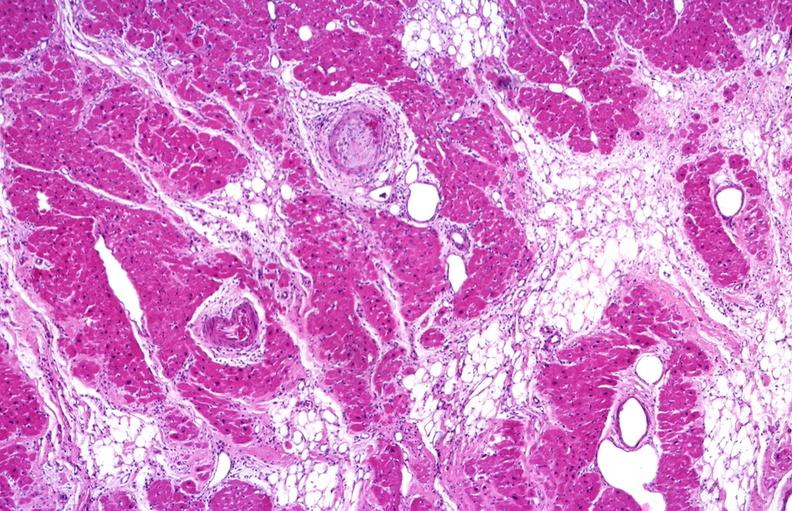s marked present?
Answer the question using a single word or phrase. No 